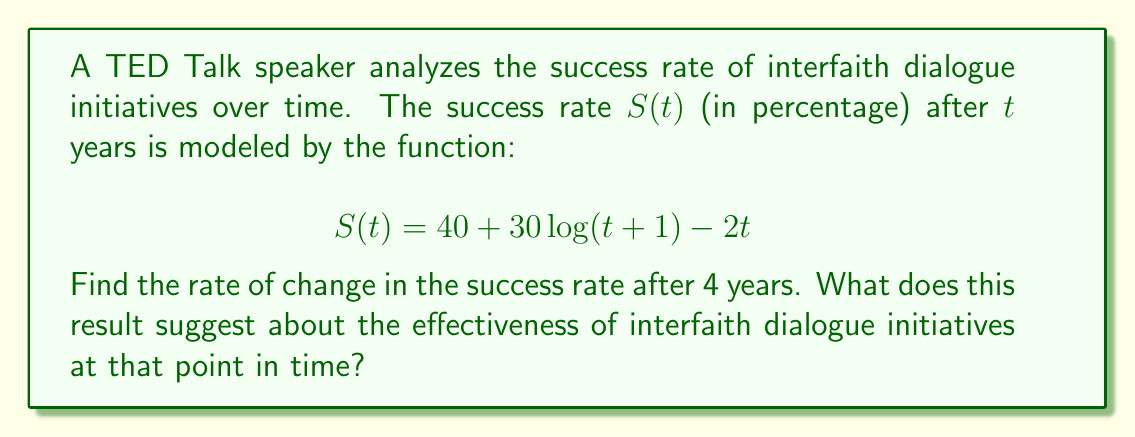Can you solve this math problem? To find the rate of change in the success rate after 4 years, we need to calculate the derivative of $S(t)$ and evaluate it at $t=4$.

Step 1: Calculate the derivative of $S(t)$
$$\frac{d}{dt}S(t) = \frac{d}{dt}(40 + 30\log(t+1) - 2t)$$

Using the sum rule and constant multiple rule:
$$\frac{d}{dt}S(t) = 0 + 30\frac{d}{dt}\log(t+1) - \frac{d}{dt}2t$$

Applying the chain rule to $\log(t+1)$ and the constant multiple rule to $2t$:
$$\frac{d}{dt}S(t) = 30 \cdot \frac{1}{t+1} \cdot \frac{d}{dt}(t+1) - 2$$
$$\frac{d}{dt}S(t) = \frac{30}{t+1} - 2$$

Step 2: Evaluate the derivative at $t=4$
$$\frac{d}{dt}S(4) = \frac{30}{4+1} - 2 = \frac{30}{5} - 2 = 6 - 2 = 4$$

The rate of change in the success rate after 4 years is 4 percentage points per year.

This positive rate of change suggests that the effectiveness of interfaith dialogue initiatives is still increasing after 4 years, indicating a continued positive impact on religious conflict resolution.
Answer: 4 percentage points per year 